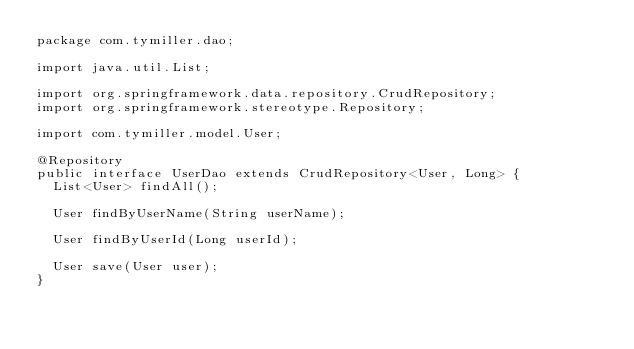Convert code to text. <code><loc_0><loc_0><loc_500><loc_500><_Java_>package com.tymiller.dao;

import java.util.List;

import org.springframework.data.repository.CrudRepository;
import org.springframework.stereotype.Repository;

import com.tymiller.model.User;

@Repository
public interface UserDao extends CrudRepository<User, Long> {
	List<User> findAll();
	
	User findByUserName(String userName);
	
	User findByUserId(Long userId);
	
	User save(User user);
}
</code> 